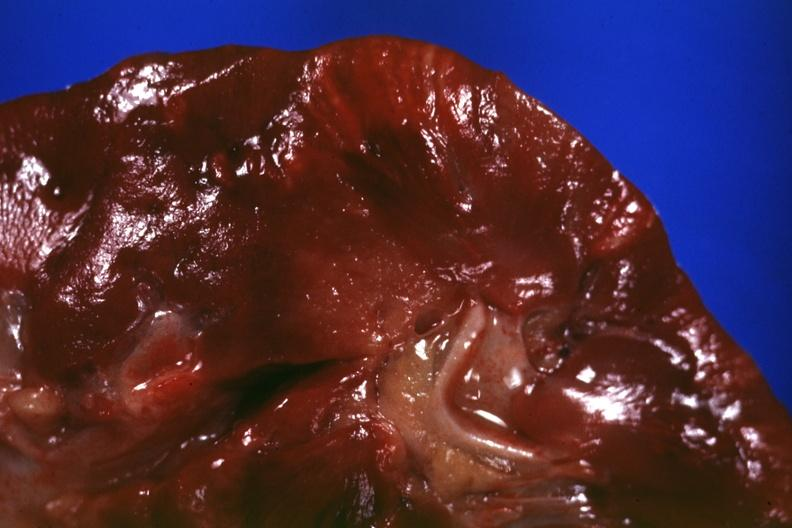s sarcoidosis present?
Answer the question using a single word or phrase. Yes 